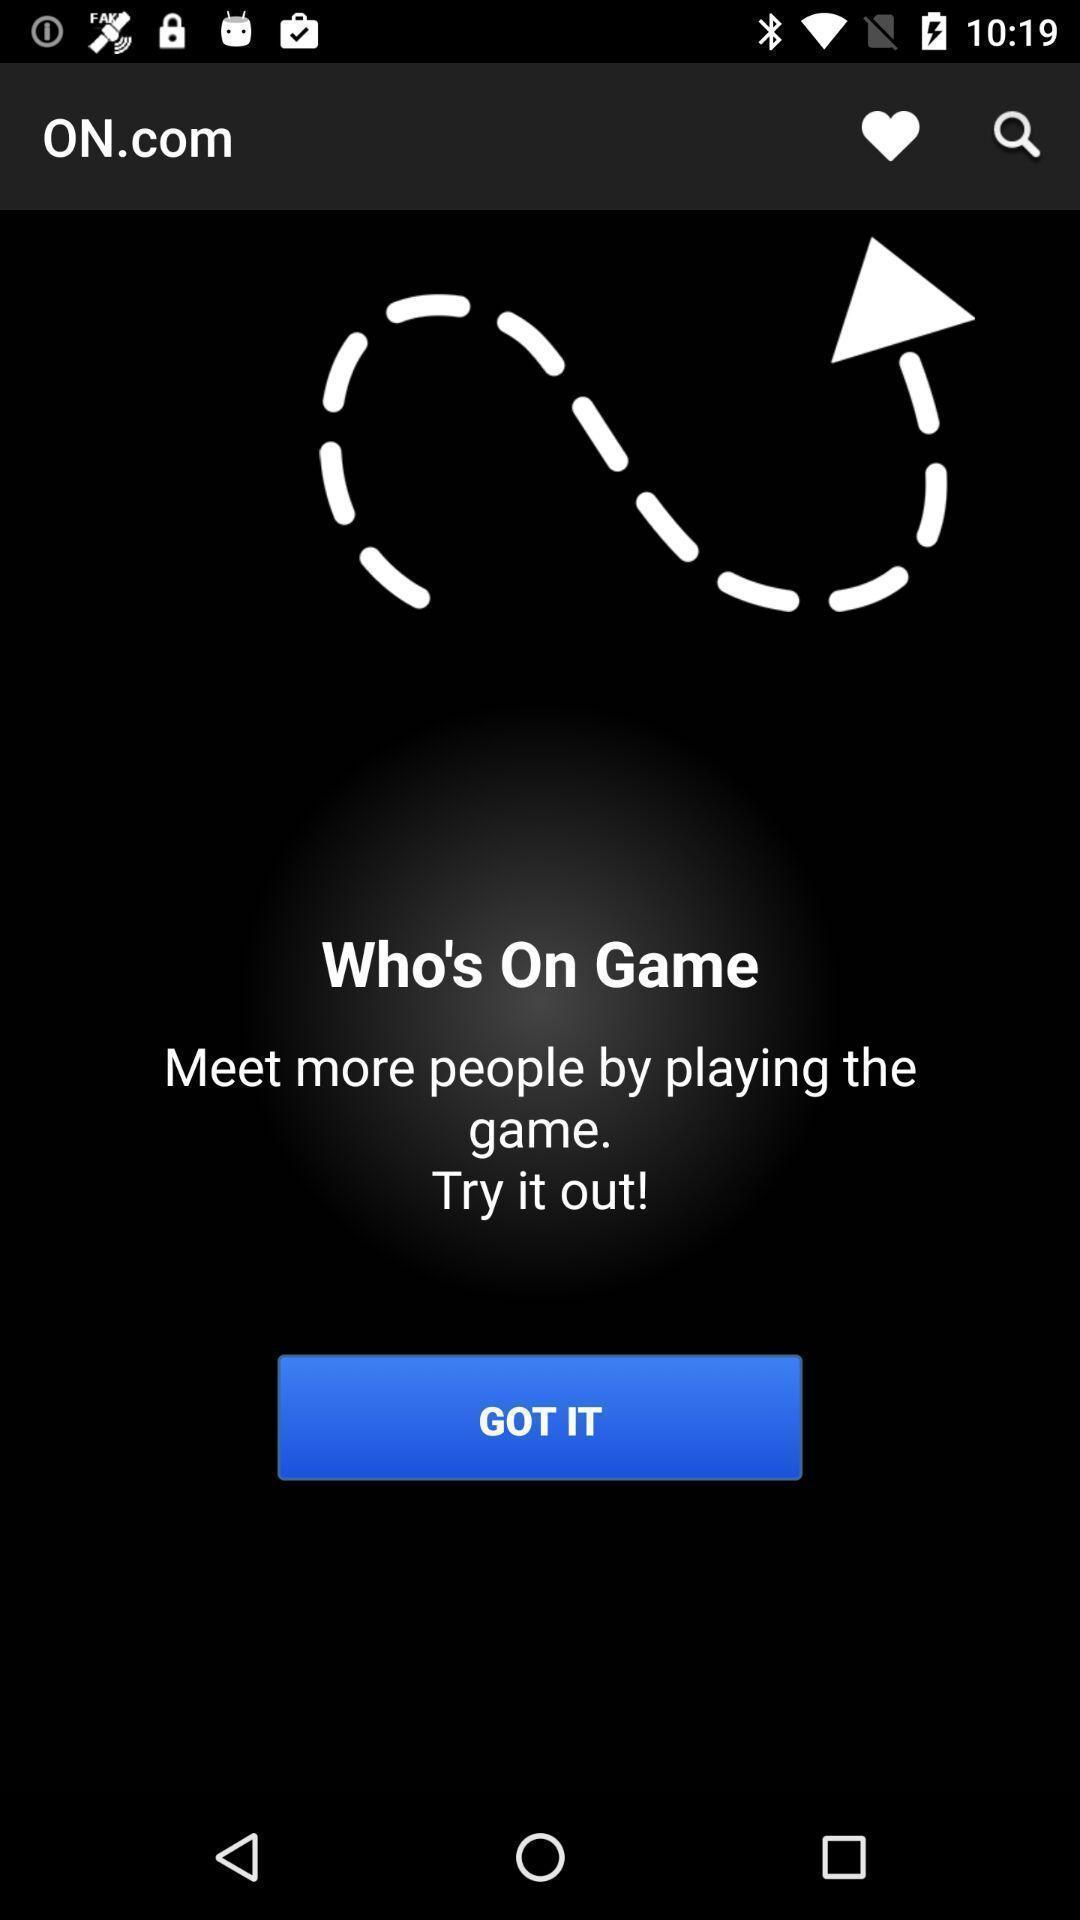Explain the elements present in this screenshot. Window displaying a online game. 